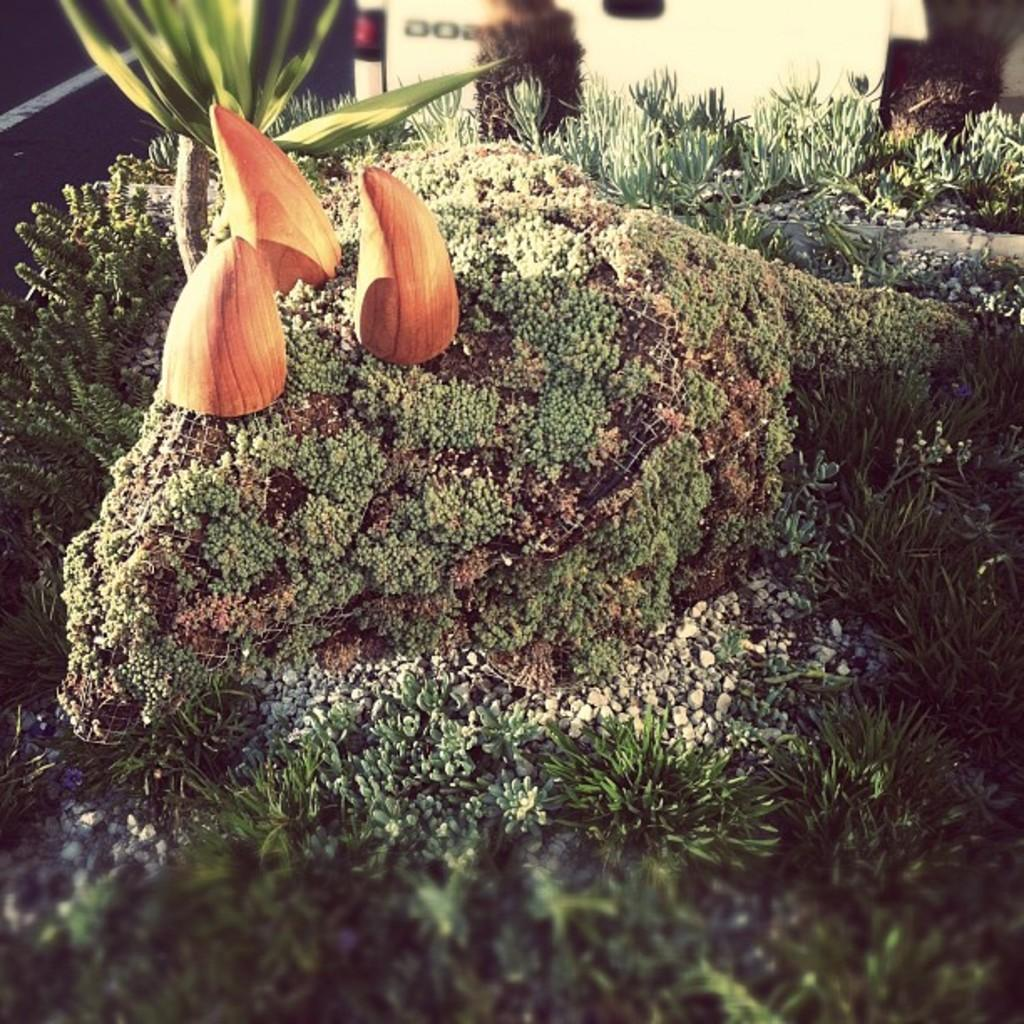What type of living organisms can be seen in the image? Plants can be seen in the image. What type of inanimate objects are present in the image? Stones and some objects are present in the image. Can you describe the background of the image? The background of the image is blurred. How many girls are visible in the image? There are no girls present in the image. What type of addition can be performed on the objects in the image? The image does not depict any mathematical operations or calculations, so there is no addition to be performed on the objects. 